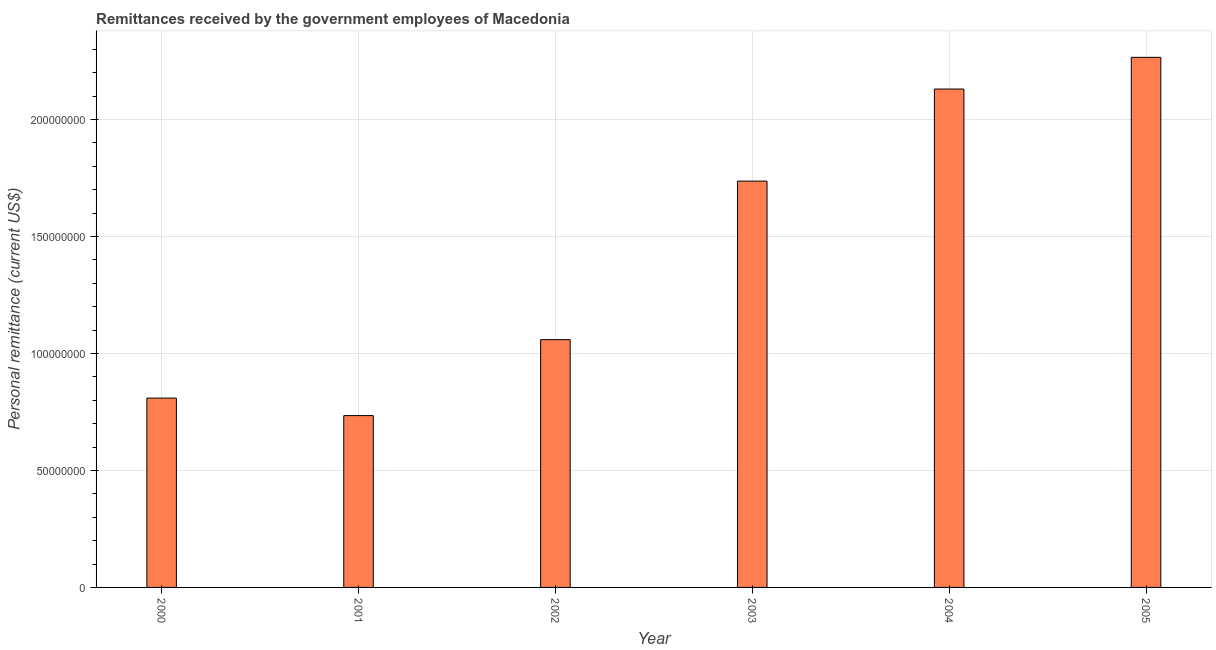What is the title of the graph?
Provide a short and direct response. Remittances received by the government employees of Macedonia. What is the label or title of the Y-axis?
Your response must be concise. Personal remittance (current US$). What is the personal remittances in 2000?
Offer a very short reply. 8.09e+07. Across all years, what is the maximum personal remittances?
Give a very brief answer. 2.27e+08. Across all years, what is the minimum personal remittances?
Offer a very short reply. 7.34e+07. In which year was the personal remittances minimum?
Make the answer very short. 2001. What is the sum of the personal remittances?
Ensure brevity in your answer.  8.74e+08. What is the difference between the personal remittances in 2002 and 2005?
Your answer should be compact. -1.21e+08. What is the average personal remittances per year?
Keep it short and to the point. 1.46e+08. What is the median personal remittances?
Offer a very short reply. 1.40e+08. In how many years, is the personal remittances greater than 110000000 US$?
Your answer should be compact. 3. What is the ratio of the personal remittances in 2003 to that in 2004?
Offer a terse response. 0.81. Is the personal remittances in 2002 less than that in 2005?
Make the answer very short. Yes. Is the difference between the personal remittances in 2000 and 2001 greater than the difference between any two years?
Your response must be concise. No. What is the difference between the highest and the second highest personal remittances?
Keep it short and to the point. 1.36e+07. Is the sum of the personal remittances in 2003 and 2004 greater than the maximum personal remittances across all years?
Offer a very short reply. Yes. What is the difference between the highest and the lowest personal remittances?
Give a very brief answer. 1.53e+08. How many bars are there?
Your answer should be compact. 6. Are all the bars in the graph horizontal?
Make the answer very short. No. How many years are there in the graph?
Ensure brevity in your answer.  6. What is the difference between two consecutive major ticks on the Y-axis?
Your answer should be very brief. 5.00e+07. What is the Personal remittance (current US$) of 2000?
Provide a short and direct response. 8.09e+07. What is the Personal remittance (current US$) of 2001?
Ensure brevity in your answer.  7.34e+07. What is the Personal remittance (current US$) in 2002?
Provide a succinct answer. 1.06e+08. What is the Personal remittance (current US$) in 2003?
Offer a terse response. 1.74e+08. What is the Personal remittance (current US$) of 2004?
Your response must be concise. 2.13e+08. What is the Personal remittance (current US$) in 2005?
Your response must be concise. 2.27e+08. What is the difference between the Personal remittance (current US$) in 2000 and 2001?
Give a very brief answer. 7.48e+06. What is the difference between the Personal remittance (current US$) in 2000 and 2002?
Make the answer very short. -2.50e+07. What is the difference between the Personal remittance (current US$) in 2000 and 2003?
Ensure brevity in your answer.  -9.27e+07. What is the difference between the Personal remittance (current US$) in 2000 and 2004?
Keep it short and to the point. -1.32e+08. What is the difference between the Personal remittance (current US$) in 2000 and 2005?
Offer a very short reply. -1.46e+08. What is the difference between the Personal remittance (current US$) in 2001 and 2002?
Offer a very short reply. -3.25e+07. What is the difference between the Personal remittance (current US$) in 2001 and 2003?
Give a very brief answer. -1.00e+08. What is the difference between the Personal remittance (current US$) in 2001 and 2004?
Your answer should be compact. -1.40e+08. What is the difference between the Personal remittance (current US$) in 2001 and 2005?
Your answer should be compact. -1.53e+08. What is the difference between the Personal remittance (current US$) in 2002 and 2003?
Your answer should be very brief. -6.78e+07. What is the difference between the Personal remittance (current US$) in 2002 and 2004?
Make the answer very short. -1.07e+08. What is the difference between the Personal remittance (current US$) in 2002 and 2005?
Provide a short and direct response. -1.21e+08. What is the difference between the Personal remittance (current US$) in 2003 and 2004?
Provide a succinct answer. -3.94e+07. What is the difference between the Personal remittance (current US$) in 2003 and 2005?
Make the answer very short. -5.29e+07. What is the difference between the Personal remittance (current US$) in 2004 and 2005?
Offer a terse response. -1.36e+07. What is the ratio of the Personal remittance (current US$) in 2000 to that in 2001?
Keep it short and to the point. 1.1. What is the ratio of the Personal remittance (current US$) in 2000 to that in 2002?
Offer a terse response. 0.76. What is the ratio of the Personal remittance (current US$) in 2000 to that in 2003?
Give a very brief answer. 0.47. What is the ratio of the Personal remittance (current US$) in 2000 to that in 2004?
Offer a very short reply. 0.38. What is the ratio of the Personal remittance (current US$) in 2000 to that in 2005?
Your answer should be very brief. 0.36. What is the ratio of the Personal remittance (current US$) in 2001 to that in 2002?
Your answer should be very brief. 0.69. What is the ratio of the Personal remittance (current US$) in 2001 to that in 2003?
Your answer should be compact. 0.42. What is the ratio of the Personal remittance (current US$) in 2001 to that in 2004?
Give a very brief answer. 0.34. What is the ratio of the Personal remittance (current US$) in 2001 to that in 2005?
Your answer should be compact. 0.32. What is the ratio of the Personal remittance (current US$) in 2002 to that in 2003?
Ensure brevity in your answer.  0.61. What is the ratio of the Personal remittance (current US$) in 2002 to that in 2004?
Your answer should be very brief. 0.5. What is the ratio of the Personal remittance (current US$) in 2002 to that in 2005?
Provide a short and direct response. 0.47. What is the ratio of the Personal remittance (current US$) in 2003 to that in 2004?
Your answer should be very brief. 0.81. What is the ratio of the Personal remittance (current US$) in 2003 to that in 2005?
Offer a terse response. 0.77. What is the ratio of the Personal remittance (current US$) in 2004 to that in 2005?
Provide a short and direct response. 0.94. 